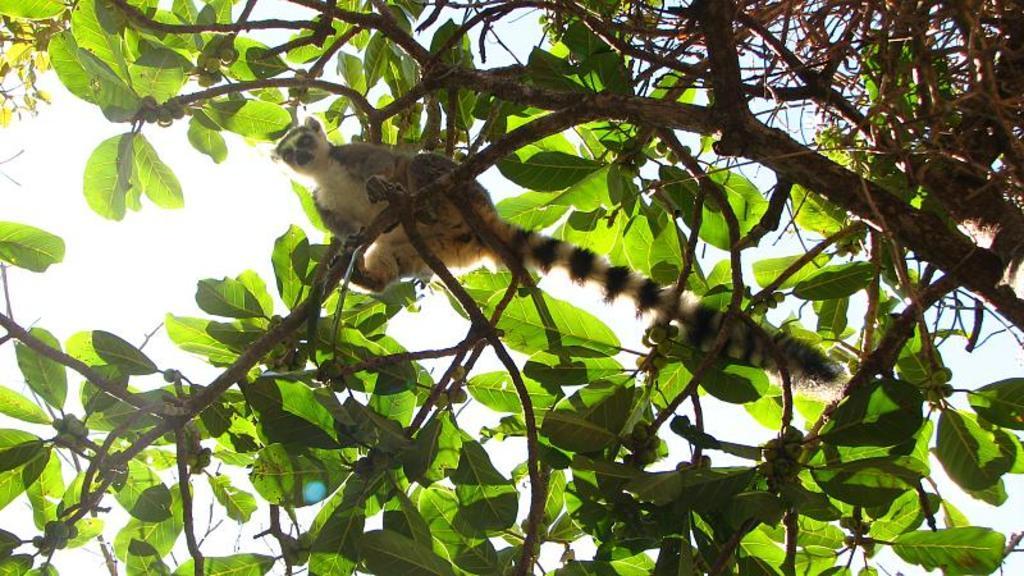Could you give a brief overview of what you see in this image? In this picture there is an animal sitting on the tree and there are fruits on the tree. At the top there is sky. 